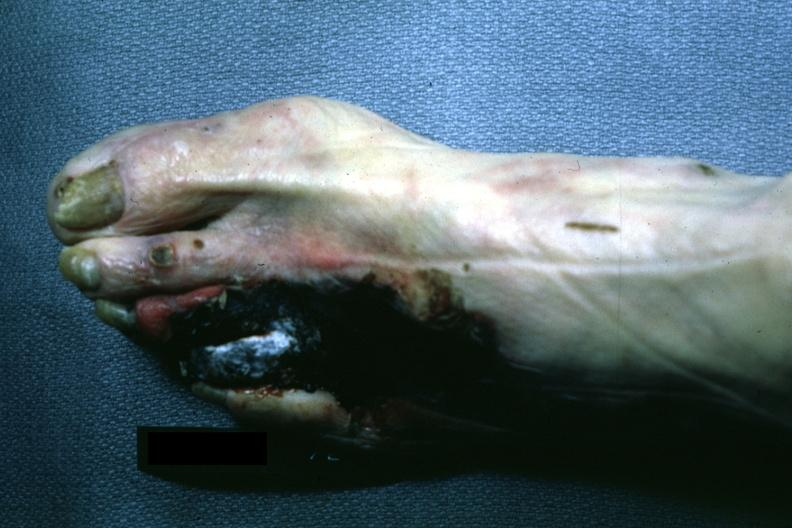what does this image show?
Answer the question using a single word or phrase. Well demarcated gangrene third and fourth toes 